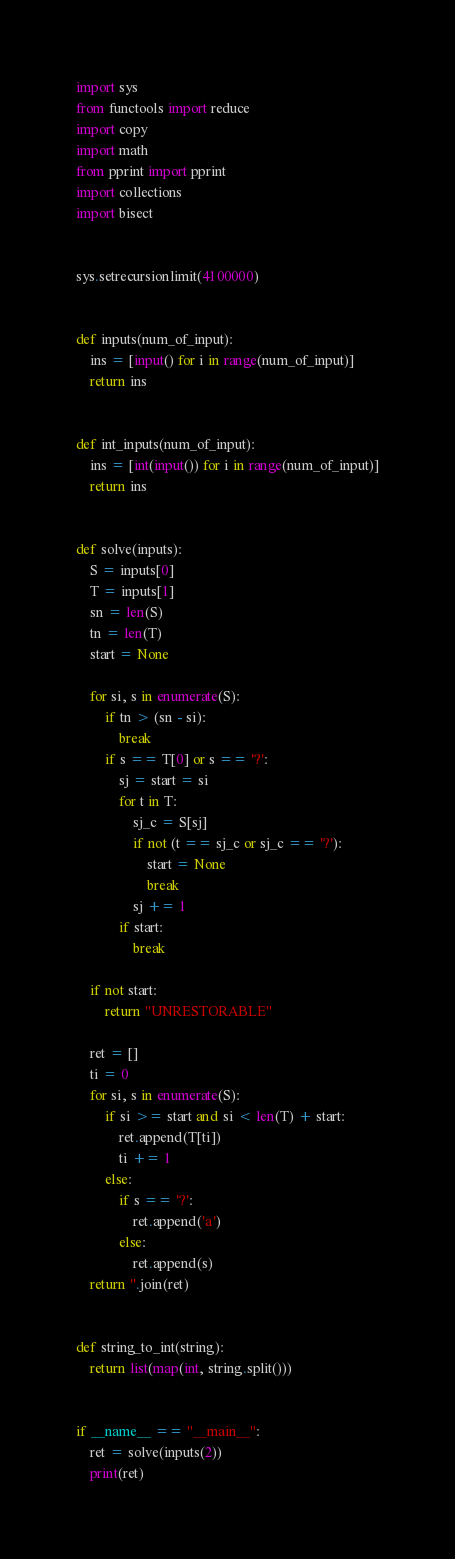<code> <loc_0><loc_0><loc_500><loc_500><_Python_>import sys
from functools import reduce
import copy
import math
from pprint import pprint
import collections
import bisect


sys.setrecursionlimit(4100000)


def inputs(num_of_input):
    ins = [input() for i in range(num_of_input)]
    return ins


def int_inputs(num_of_input):
    ins = [int(input()) for i in range(num_of_input)]
    return ins


def solve(inputs):
    S = inputs[0]
    T = inputs[1]
    sn = len(S)
    tn = len(T)
    start = None

    for si, s in enumerate(S):
        if tn > (sn - si):
            break
        if s == T[0] or s == '?':
            sj = start = si
            for t in T:
                sj_c = S[sj]
                if not (t == sj_c or sj_c == '?'):
                    start = None
                    break
                sj += 1
            if start:
                break

    if not start:
        return "UNRESTORABLE"

    ret = []
    ti = 0
    for si, s in enumerate(S):
        if si >= start and si < len(T) + start:
            ret.append(T[ti])
            ti += 1
        else:
            if s == '?':
                ret.append('a')
            else:
                ret.append(s)
    return ''.join(ret)


def string_to_int(string):
    return list(map(int, string.split()))


if __name__ == "__main__":
    ret = solve(inputs(2))
    print(ret)
</code> 